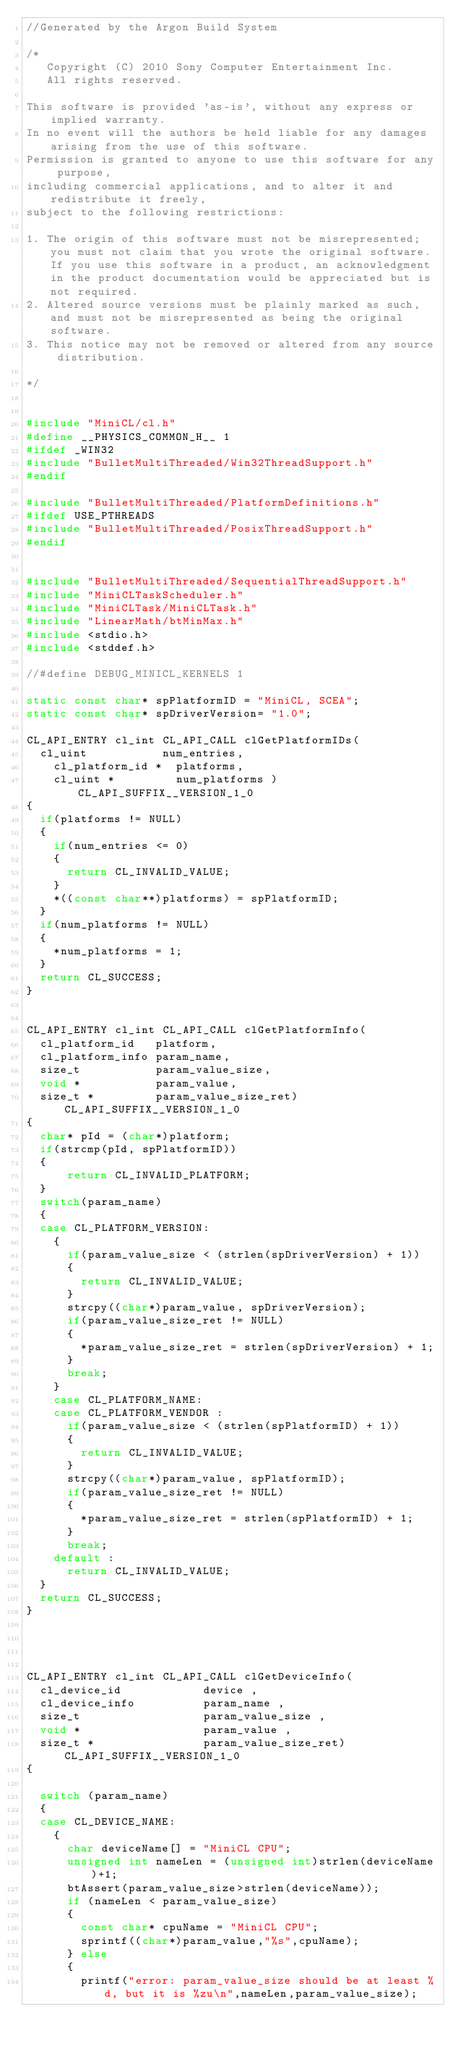<code> <loc_0><loc_0><loc_500><loc_500><_C++_>//Generated by the Argon Build System

/*
   Copyright (C) 2010 Sony Computer Entertainment Inc.
   All rights reserved.

This software is provided 'as-is', without any express or implied warranty.
In no event will the authors be held liable for any damages arising from the use of this software.
Permission is granted to anyone to use this software for any purpose, 
including commercial applications, and to alter it and redistribute it freely, 
subject to the following restrictions:

1. The origin of this software must not be misrepresented; you must not claim that you wrote the original software. If you use this software in a product, an acknowledgment in the product documentation would be appreciated but is not required.
2. Altered source versions must be plainly marked as such, and must not be misrepresented as being the original software.
3. This notice may not be removed or altered from any source distribution.

*/


#include "MiniCL/cl.h"
#define __PHYSICS_COMMON_H__ 1
#ifdef _WIN32
#include "BulletMultiThreaded/Win32ThreadSupport.h"
#endif

#include "BulletMultiThreaded/PlatformDefinitions.h"
#ifdef USE_PTHREADS
#include "BulletMultiThreaded/PosixThreadSupport.h"
#endif


#include "BulletMultiThreaded/SequentialThreadSupport.h"
#include "MiniCLTaskScheduler.h"
#include "MiniCLTask/MiniCLTask.h"
#include "LinearMath/btMinMax.h"
#include <stdio.h>
#include <stddef.h>

//#define DEBUG_MINICL_KERNELS 1

static const char* spPlatformID = "MiniCL, SCEA";
static const char* spDriverVersion= "1.0";

CL_API_ENTRY cl_int CL_API_CALL clGetPlatformIDs(
	cl_uint           num_entries,
    cl_platform_id *  platforms,
    cl_uint *         num_platforms ) CL_API_SUFFIX__VERSION_1_0
{
	if(platforms != NULL)
	{
		if(num_entries <= 0)
		{
			return CL_INVALID_VALUE; 
		}
		*((const char**)platforms) = spPlatformID;
	}
	if(num_platforms != NULL)
	{
		*num_platforms = 1;
	}
	return CL_SUCCESS;
}


CL_API_ENTRY cl_int CL_API_CALL clGetPlatformInfo(
	cl_platform_id   platform, 
	cl_platform_info param_name,
	size_t           param_value_size, 
	void *           param_value,
	size_t *         param_value_size_ret) CL_API_SUFFIX__VERSION_1_0
{
	char* pId = (char*)platform;
	if(strcmp(pId, spPlatformID))
	{
			return CL_INVALID_PLATFORM; 
	}
	switch(param_name)
	{
	case CL_PLATFORM_VERSION:
		{
			if(param_value_size < (strlen(spDriverVersion) + 1))
			{
				return CL_INVALID_VALUE; 
			}
			strcpy((char*)param_value, spDriverVersion);
			if(param_value_size_ret != NULL)
			{
				*param_value_size_ret = strlen(spDriverVersion) + 1;
			}
			break;
		}
		case CL_PLATFORM_NAME:
		case CL_PLATFORM_VENDOR	:
			if(param_value_size < (strlen(spPlatformID) + 1))
			{
				return CL_INVALID_VALUE; 
			}
			strcpy((char*)param_value, spPlatformID);
			if(param_value_size_ret != NULL)
			{
				*param_value_size_ret = strlen(spPlatformID) + 1;
			}
			break;
		default : 
			return CL_INVALID_VALUE; 
	}
	return CL_SUCCESS;
}




CL_API_ENTRY cl_int CL_API_CALL clGetDeviceInfo(
	cl_device_id            device ,
	cl_device_info          param_name ,
	size_t                  param_value_size ,
	void *                  param_value ,
	size_t *                param_value_size_ret) CL_API_SUFFIX__VERSION_1_0
{

	switch (param_name)
	{
	case CL_DEVICE_NAME:
		{
			char deviceName[] = "MiniCL CPU";
			unsigned int nameLen = (unsigned int)strlen(deviceName)+1;
			btAssert(param_value_size>strlen(deviceName));
			if (nameLen < param_value_size)
			{
				const char* cpuName = "MiniCL CPU";
				sprintf((char*)param_value,"%s",cpuName);
			} else
			{
				printf("error: param_value_size should be at least %d, but it is %zu\n",nameLen,param_value_size);</code> 